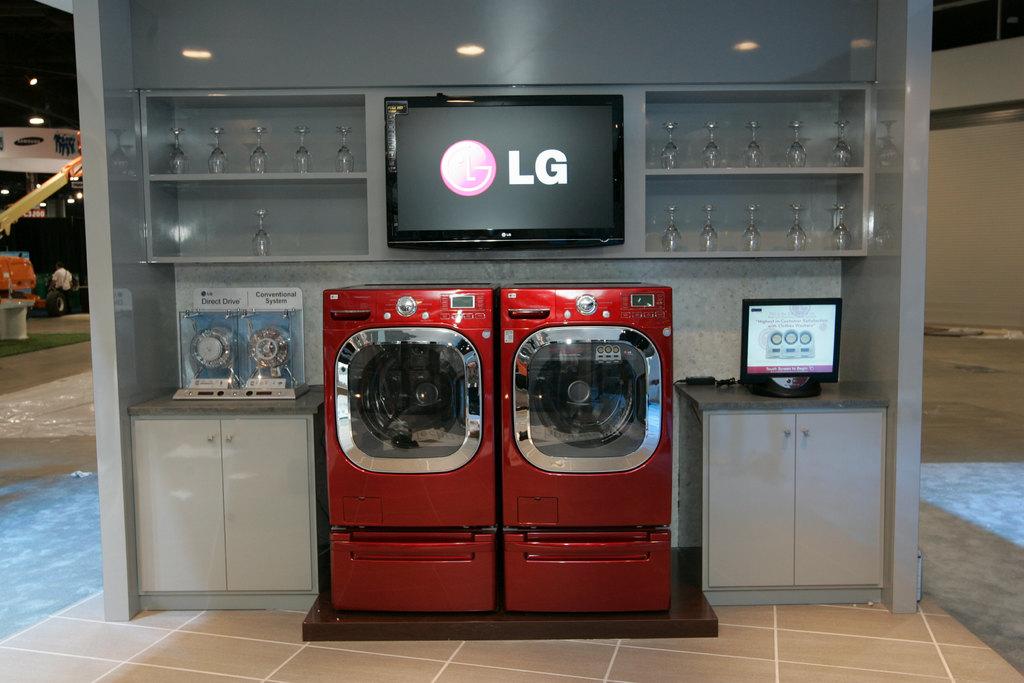Who manufactured the tv screen on the wall?
Your answer should be very brief. Lg. What kind of drives are left of the washer and dryer?
Your answer should be very brief. Direct. 